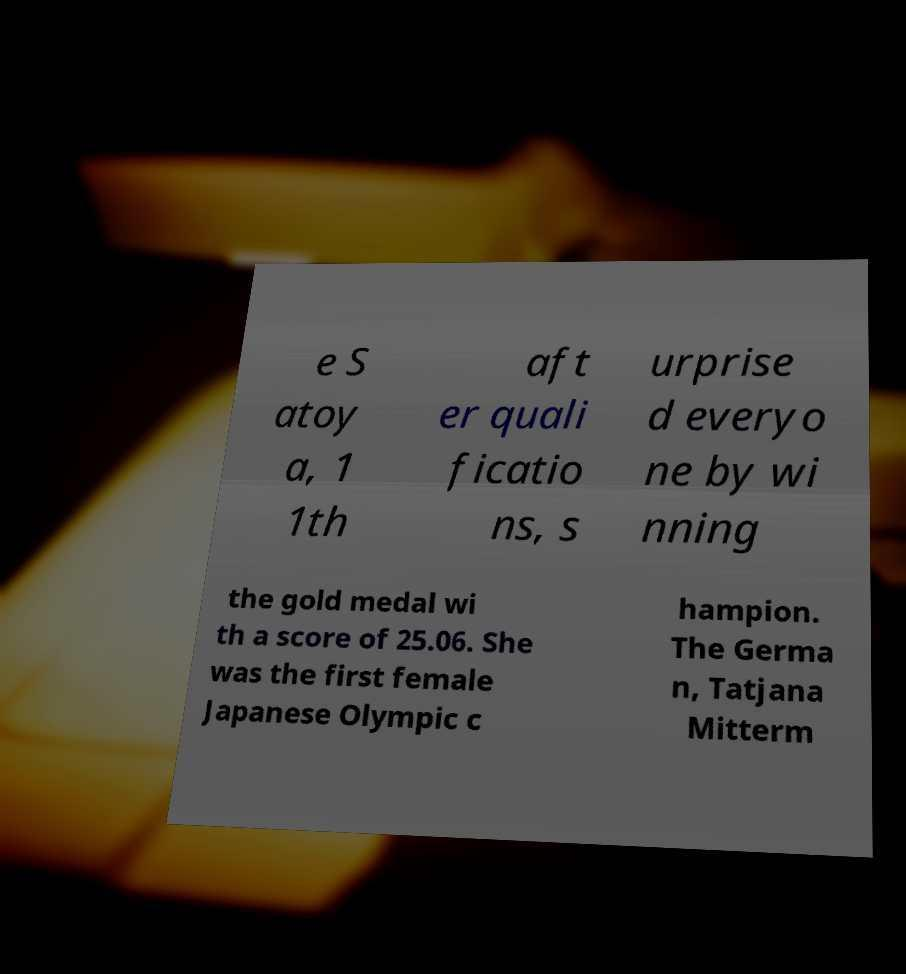What messages or text are displayed in this image? I need them in a readable, typed format. e S atoy a, 1 1th aft er quali ficatio ns, s urprise d everyo ne by wi nning the gold medal wi th a score of 25.06. She was the first female Japanese Olympic c hampion. The Germa n, Tatjana Mitterm 